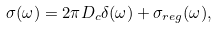Convert formula to latex. <formula><loc_0><loc_0><loc_500><loc_500>\sigma ( \omega ) = 2 \pi D _ { c } \delta ( \omega ) + \sigma _ { r e g } ( \omega ) ,</formula> 